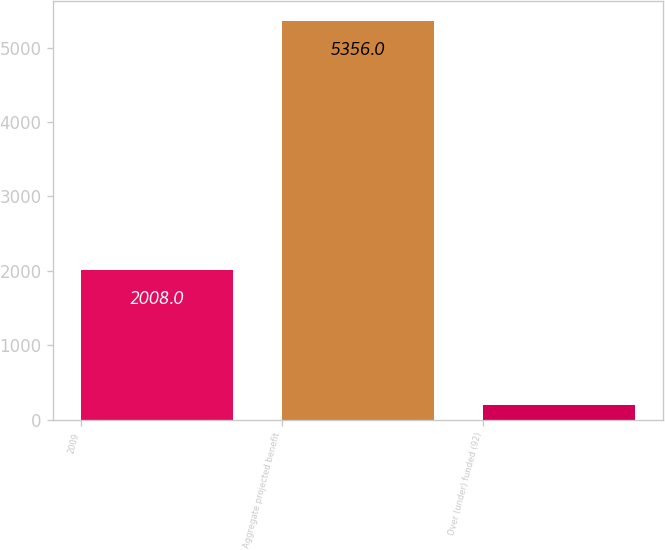Convert chart to OTSL. <chart><loc_0><loc_0><loc_500><loc_500><bar_chart><fcel>2009<fcel>Aggregate projected benefit<fcel>Over (under) funded (92)<nl><fcel>2008<fcel>5356<fcel>203<nl></chart> 